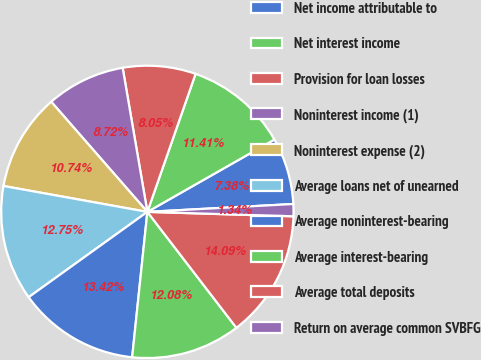<chart> <loc_0><loc_0><loc_500><loc_500><pie_chart><fcel>Net income attributable to<fcel>Net interest income<fcel>Provision for loan losses<fcel>Noninterest income (1)<fcel>Noninterest expense (2)<fcel>Average loans net of unearned<fcel>Average noninterest-bearing<fcel>Average interest-bearing<fcel>Average total deposits<fcel>Return on average common SVBFG<nl><fcel>7.38%<fcel>11.41%<fcel>8.05%<fcel>8.72%<fcel>10.74%<fcel>12.75%<fcel>13.42%<fcel>12.08%<fcel>14.09%<fcel>1.34%<nl></chart> 